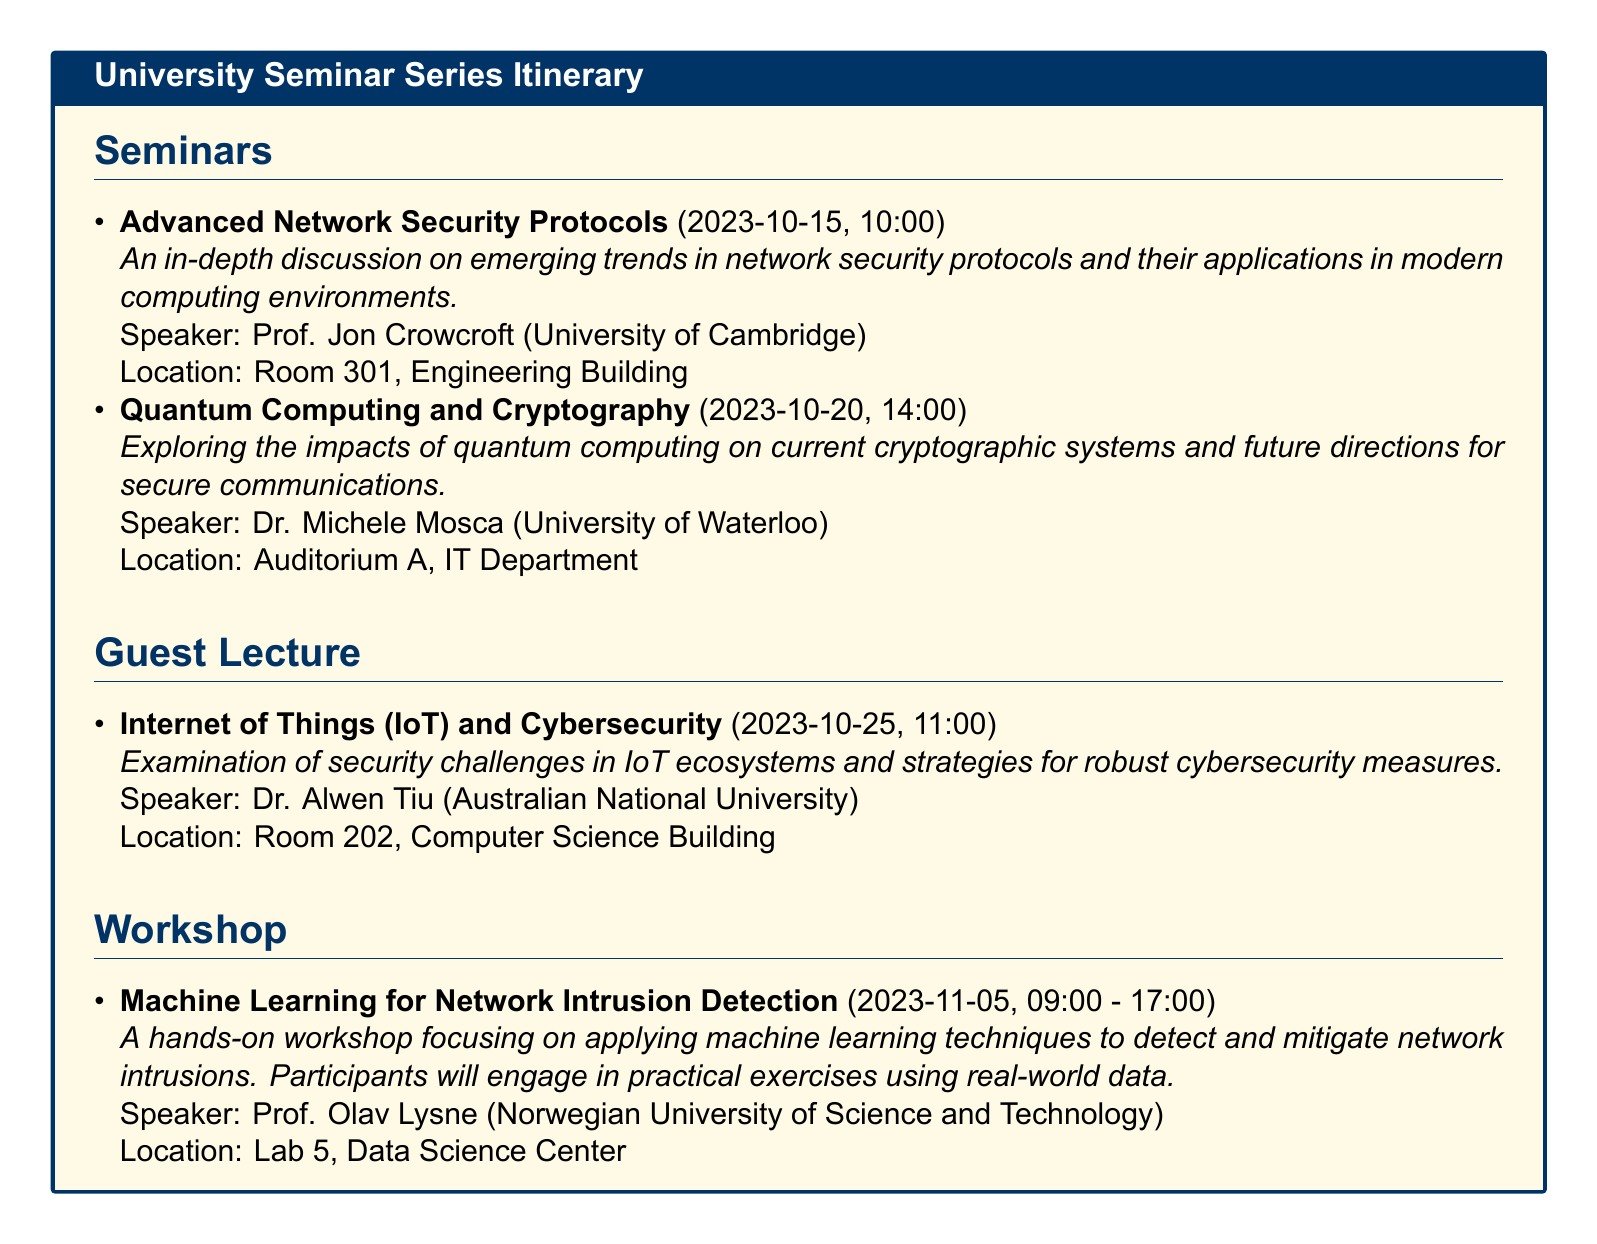What is the title of the first seminar? The title of the first seminar can be found in the seminars section of the document, which is "Advanced Network Security Protocols".
Answer: Advanced Network Security Protocols Who is the speaker for the workshop? The speaker for the workshop is listed in the workshop section; it is "Prof. Olav Lysne".
Answer: Prof. Olav Lysne What is the date of the guest lecture? The guest lecture date is specified in the document as "2023-10-25".
Answer: 2023-10-25 What is the location of the seminar on Quantum Computing? The location for the Quantum Computing seminar is noted in the document, which specifies "Auditorium A, IT Department".
Answer: Auditorium A, IT Department What topic will be covered in the workshop? The topic of the workshop is given in the document, which is "Machine Learning for Network Intrusion Detection".
Answer: Machine Learning for Network Intrusion Detection Which university is hosting Dr. Alwen Tiu's lecture? Dr. Alwen Tiu's affiliation is provided in the document as "Australian National University".
Answer: Australian National University How many seminars are listed in the itinerary? The number of seminars can be tallied from the seminars section, where two seminars are noted.
Answer: Two What is the time for the seminar on Advanced Network Security Protocols? The time for this seminar is detailed in the itinerary as "10:00".
Answer: 10:00 What is the duration of the workshop? The duration of the workshop is indicated in the document as "09:00 - 17:00".
Answer: 09:00 - 17:00 